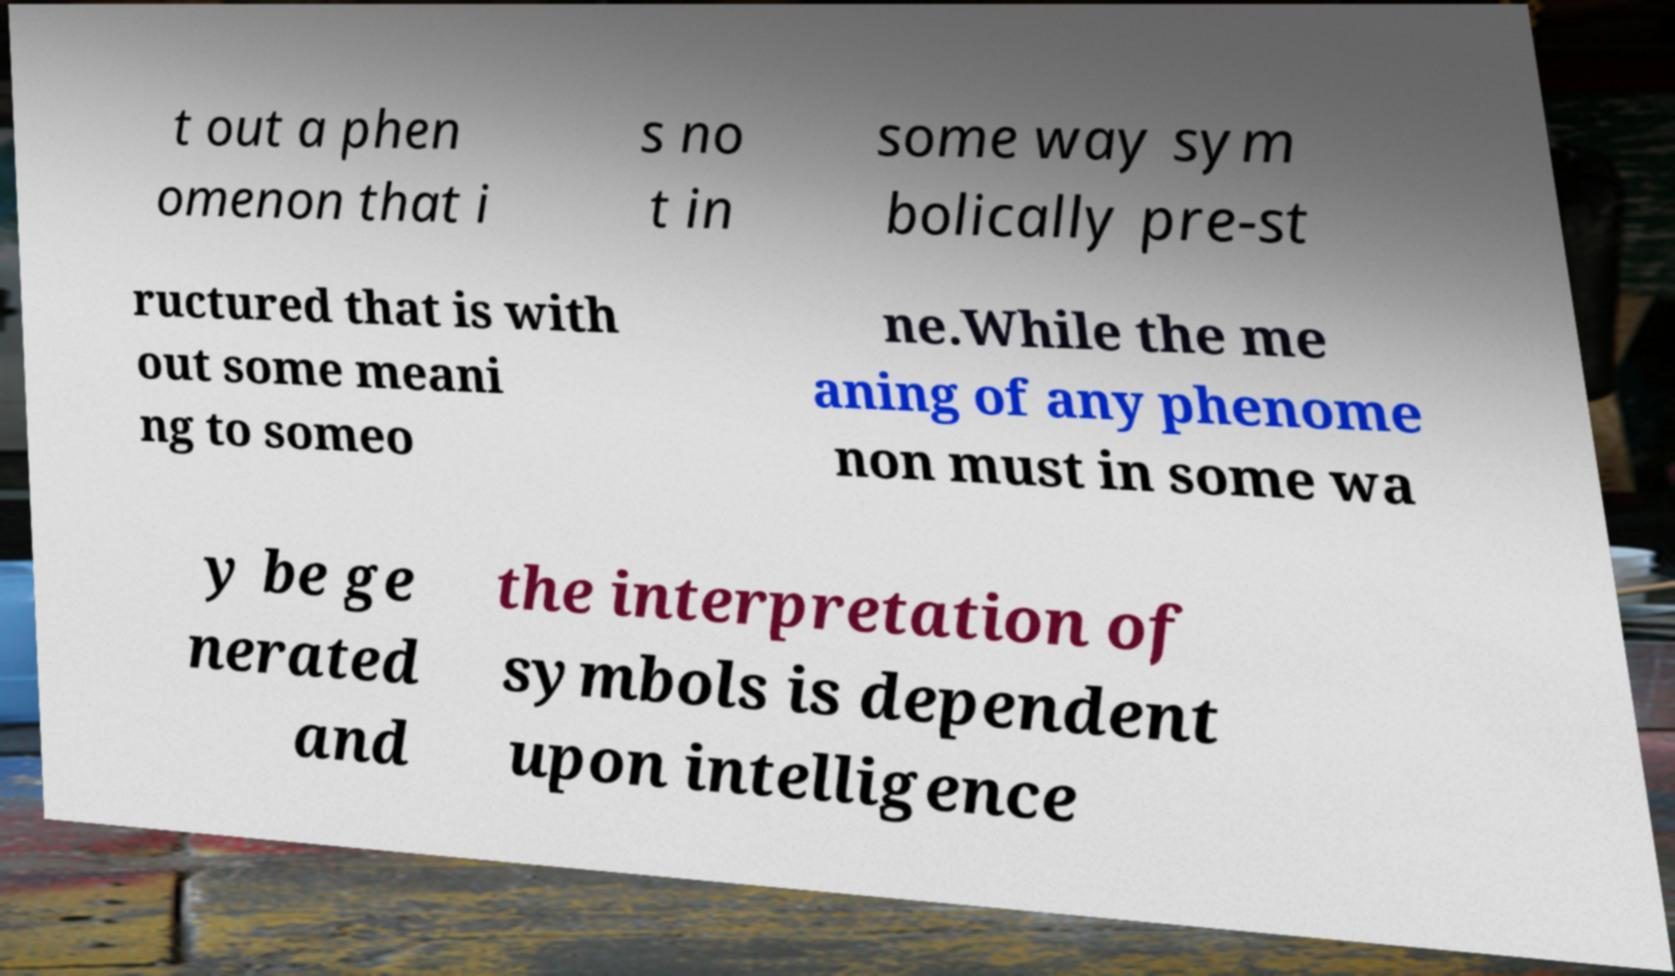I need the written content from this picture converted into text. Can you do that? t out a phen omenon that i s no t in some way sym bolically pre-st ructured that is with out some meani ng to someo ne.While the me aning of any phenome non must in some wa y be ge nerated and the interpretation of symbols is dependent upon intelligence 